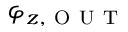<formula> <loc_0><loc_0><loc_500><loc_500>\varphi _ { z , O U T }</formula> 